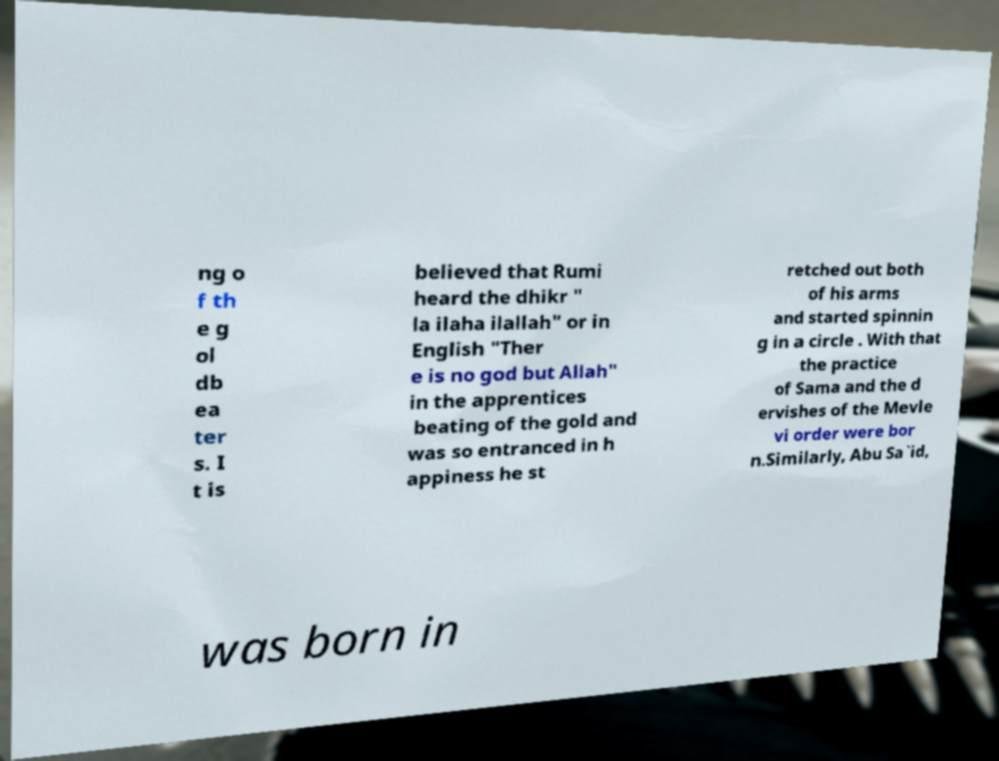Could you assist in decoding the text presented in this image and type it out clearly? ng o f th e g ol db ea ter s. I t is believed that Rumi heard the dhikr " la ilaha ilallah" or in English "Ther e is no god but Allah" in the apprentices beating of the gold and was so entranced in h appiness he st retched out both of his arms and started spinnin g in a circle . With that the practice of Sama and the d ervishes of the Mevle vi order were bor n.Similarly, Abu Sa`id, was born in 